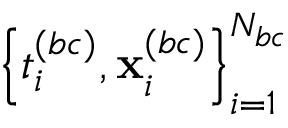Convert formula to latex. <formula><loc_0><loc_0><loc_500><loc_500>\left \{ { t } _ { i } ^ { ( b c ) } , { x } _ { i } ^ { ( b c ) } \right \} _ { i = 1 } ^ { N _ { b c } }</formula> 